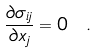Convert formula to latex. <formula><loc_0><loc_0><loc_500><loc_500>\frac { \partial \sigma _ { i j } } { \partial x _ { j } } = 0 \ .</formula> 